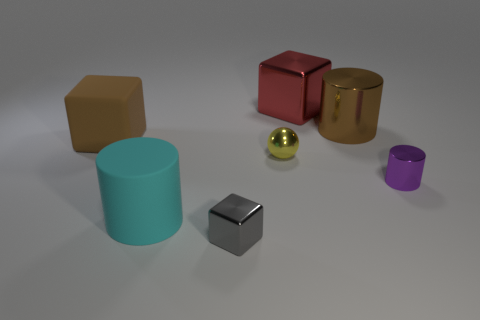The object that is both to the left of the gray metal cube and in front of the purple object is what color?
Give a very brief answer. Cyan. What material is the large thing that is in front of the tiny purple shiny object in front of the brown thing right of the gray thing made of?
Your response must be concise. Rubber. What material is the large brown cube?
Offer a very short reply. Rubber. There is a red thing that is the same shape as the large brown rubber object; what is its size?
Offer a terse response. Large. Does the large metallic cylinder have the same color as the tiny block?
Give a very brief answer. No. How many other things are the same material as the red object?
Offer a very short reply. 4. Is the number of rubber objects that are in front of the sphere the same as the number of brown cylinders?
Your answer should be compact. Yes. Is the size of the metallic block behind the brown block the same as the brown metal cylinder?
Give a very brief answer. Yes. What number of gray cubes are behind the small gray thing?
Provide a short and direct response. 0. There is a thing that is both left of the gray cube and behind the cyan cylinder; what material is it?
Make the answer very short. Rubber. 